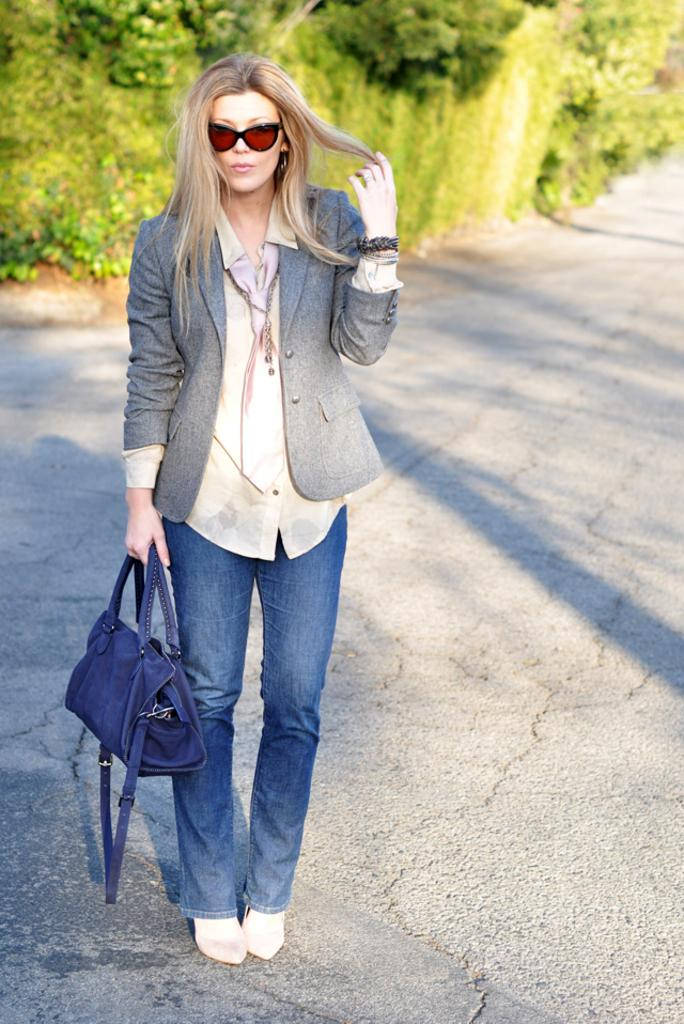Who is present in the image? There is a woman in the image. What is the woman holding in the image? The woman is holding a blue bag. Where is the woman standing in the image? The woman is standing on a road. What can be seen in the background of the image? There are trees in the background of the image. What is the title of the book the woman is reading in the image? There is no book present in the image, so it is not possible to determine the title. 